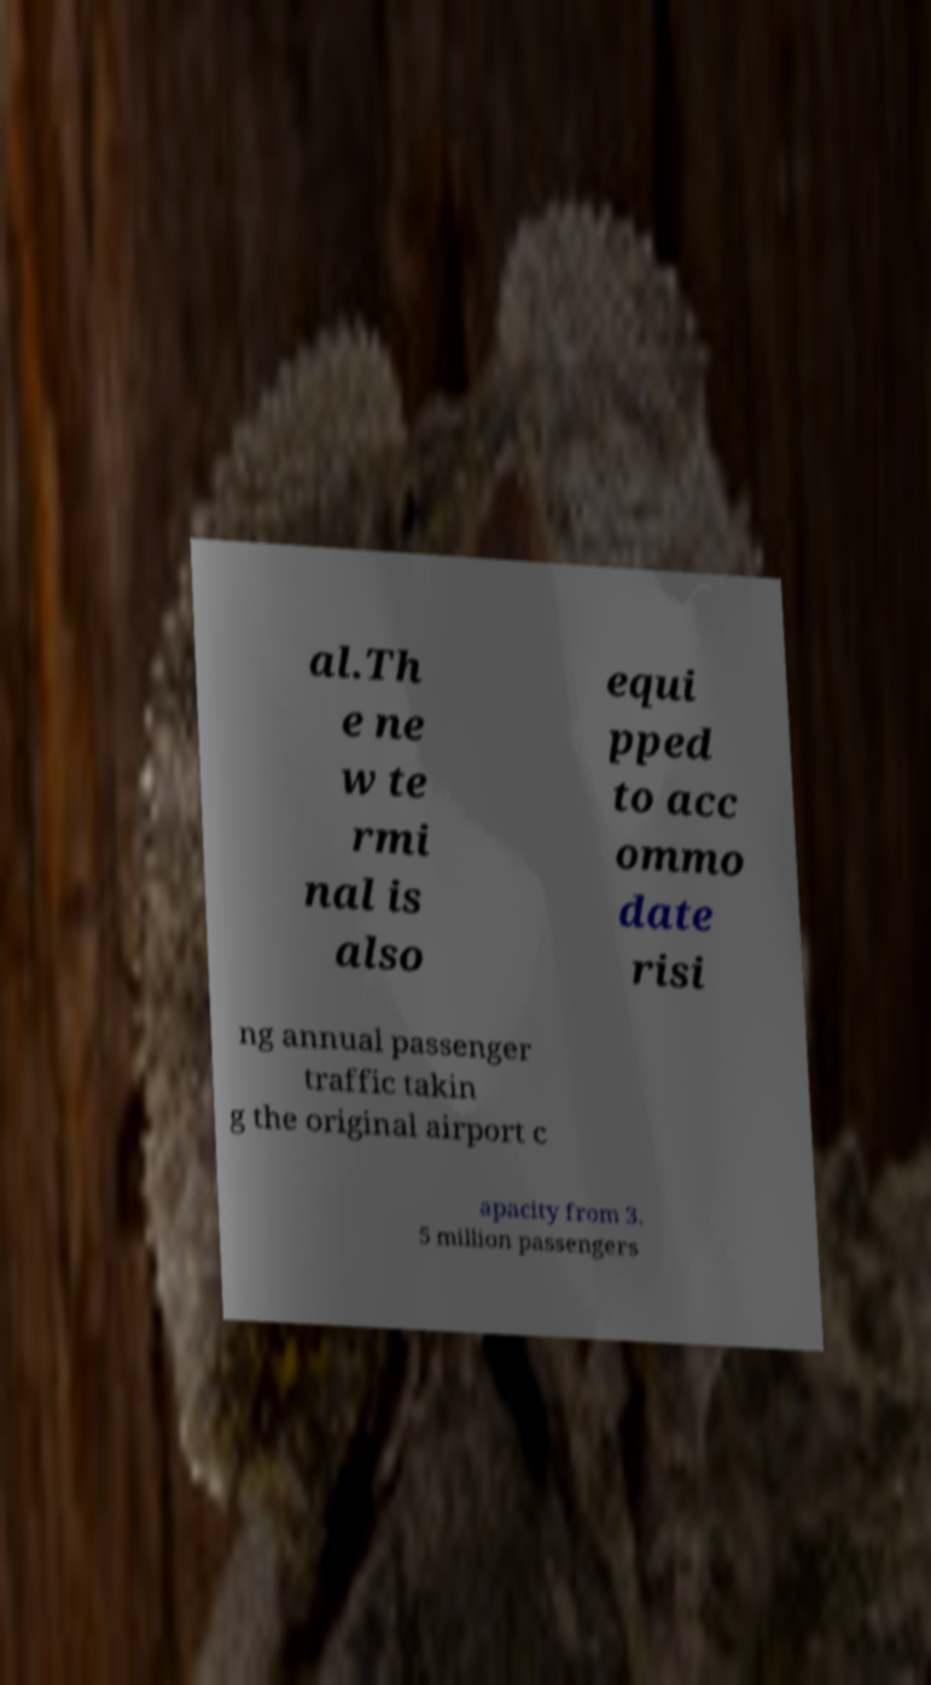For documentation purposes, I need the text within this image transcribed. Could you provide that? al.Th e ne w te rmi nal is also equi pped to acc ommo date risi ng annual passenger traffic takin g the original airport c apacity from 3. 5 million passengers 